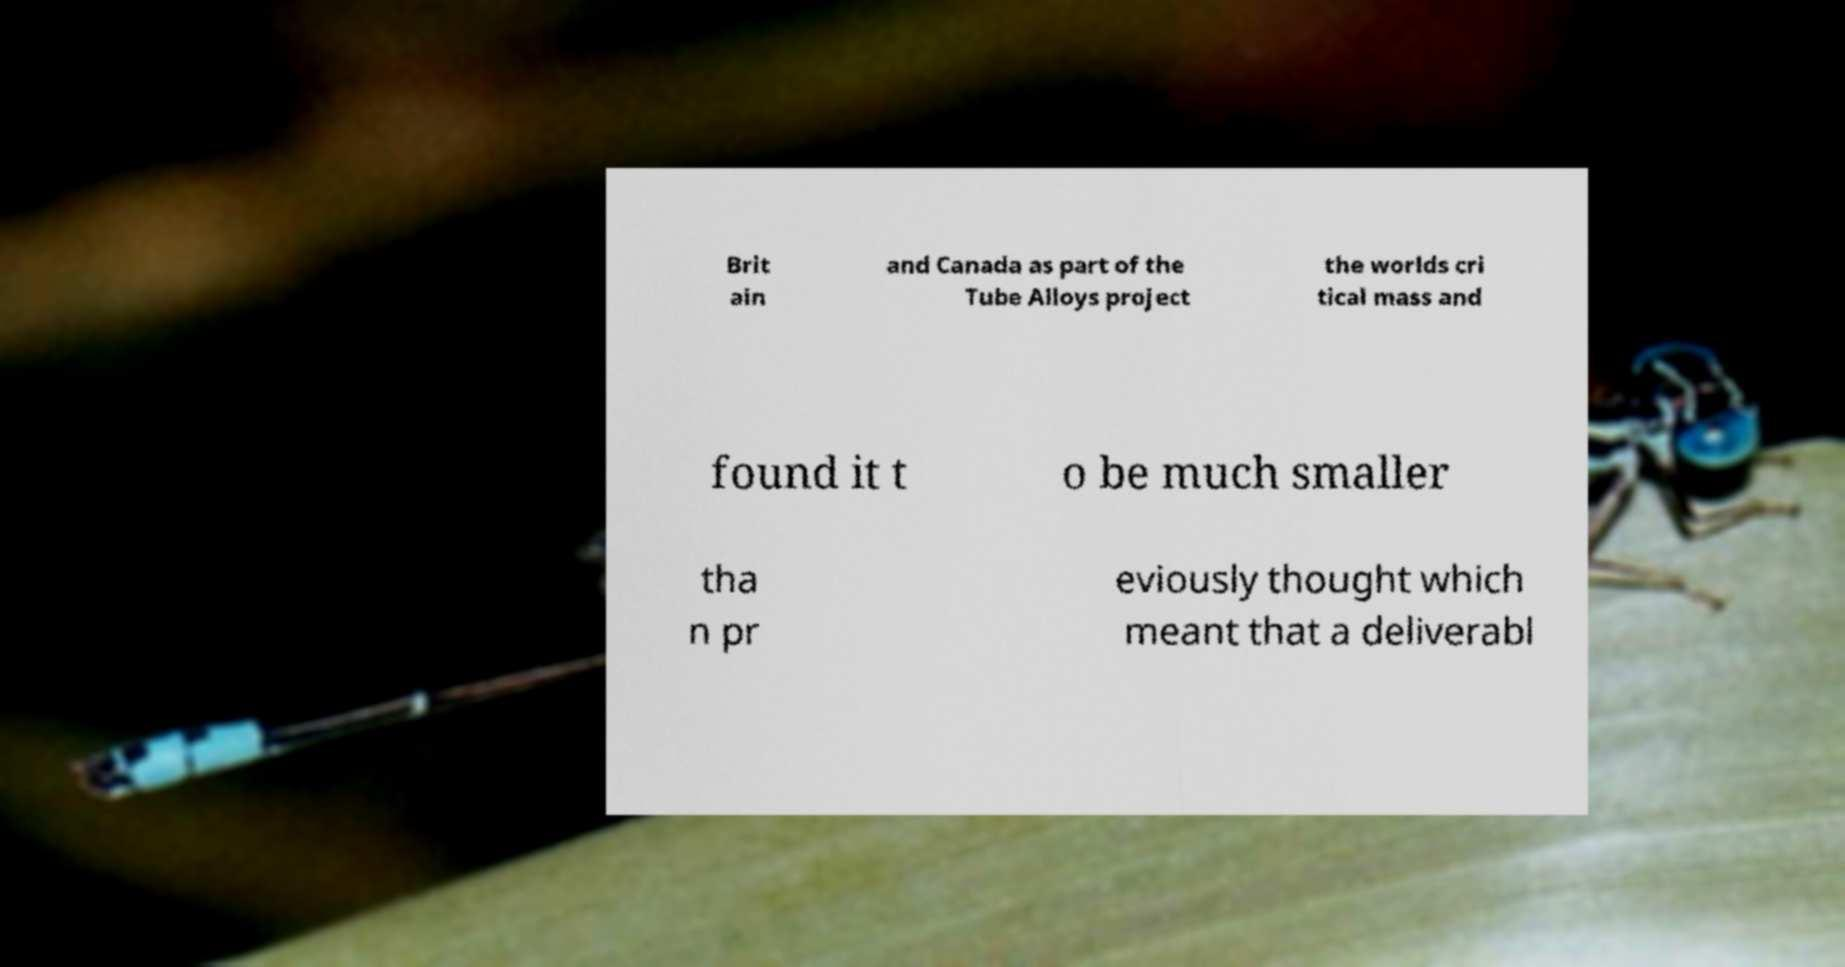Could you assist in decoding the text presented in this image and type it out clearly? Brit ain and Canada as part of the Tube Alloys project the worlds cri tical mass and found it t o be much smaller tha n pr eviously thought which meant that a deliverabl 